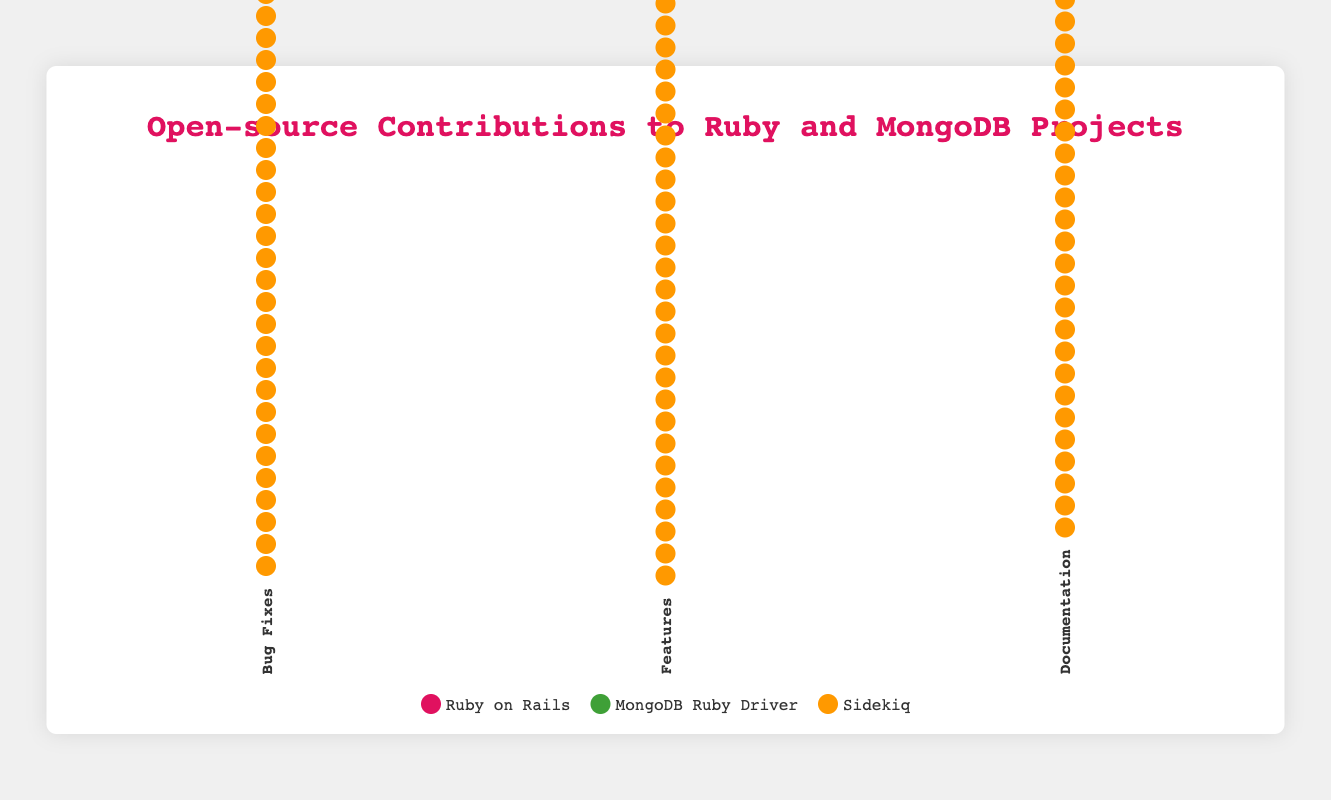How many total contributions are there to the Ruby on Rails project? Summing up the contributions to Ruby on Rails across all types: 120 (Bug Fixes) + 80 (Features) + 150 (Documentation) gives 350 contributions in total.
Answer: 350 Which project has the highest number of bug fixes? From the data, Ruby on Rails has 120 bug fixes, MongoDB Ruby Driver has 85, and Sidekiq has 50. The highest number is 120 for Ruby on Rails.
Answer: Ruby on Rails What is the total number of contributions across all projects for documentation? Summing up the contributions to documentation: 150 (Ruby on Rails) + 100 (MongoDB Ruby Driver) + 70 (Sidekiq) gives 320 contributions.
Answer: 320 How many more feature contributions does Ruby on Rails have compared to Sidekiq? Ruby on Rails has 80 feature contributions, and Sidekiq has 35. The difference is 80 - 35 = 45.
Answer: 45 Which type of contribution has the lowest number for MongoDB Ruby Driver? MongoDB Ruby Driver has 85 bug fixes, 60 features, and 100 documentation contributions. The lowest number is 60 (Features).
Answer: Features What is the difference in the number of documentation contributions between Ruby on Rails and MongoDB Ruby Driver? Ruby on Rails has 150 documentation contributions, while MongoDB Ruby Driver has 100. The difference is 150 - 100 = 50.
Answer: 50 How many total contributions exist across all types for the Sidekiq project? Summing up the contributions to Sidekiq across all types: 50 (Bug Fixes) + 35 (Features) + 70 (Documentation) gives 155 contributions in total.
Answer: 155 Which project has the least number of contributions across all types? Summing up the contributions for each project: Ruby on Rails (120 + 80 + 150 = 350), MongoDB Ruby Driver (85 + 60 + 100 = 245), Sidekiq (50 + 35 + 70 = 155). The least is Sidekiq with 155 contributions.
Answer: Sidekiq 